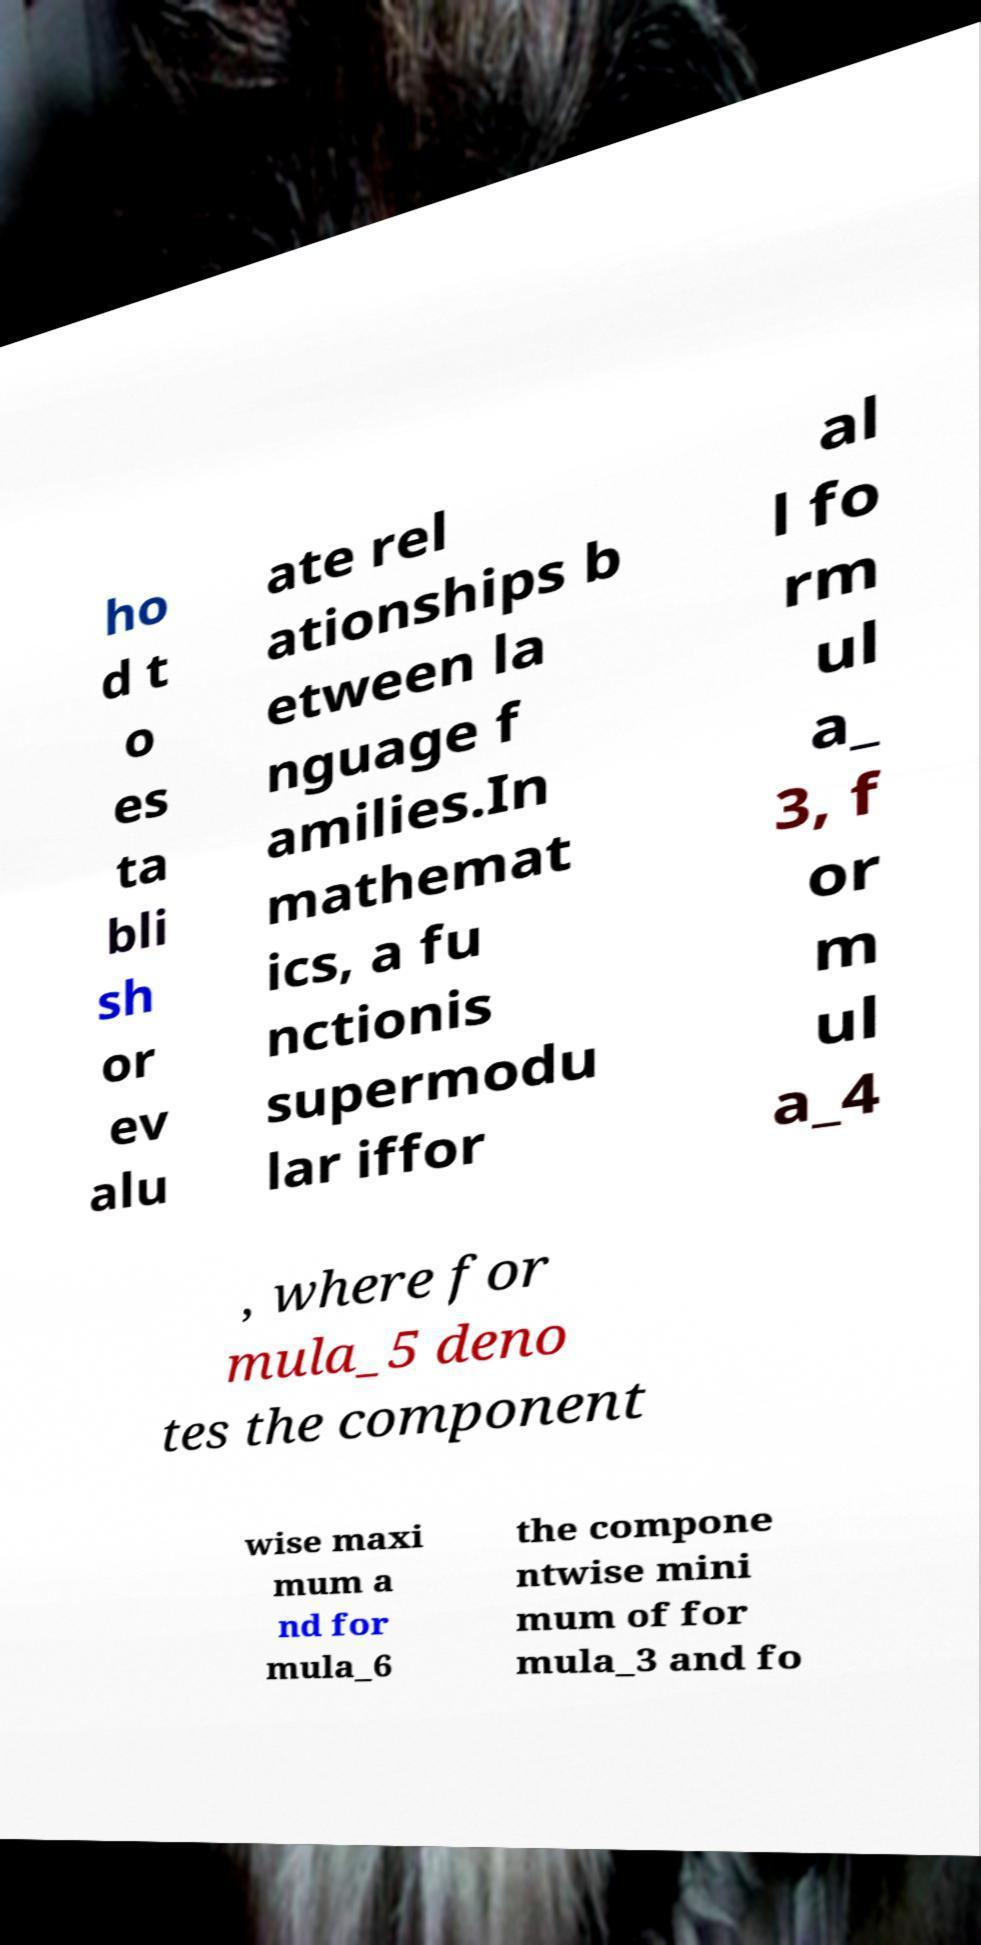Can you read and provide the text displayed in the image?This photo seems to have some interesting text. Can you extract and type it out for me? ho d t o es ta bli sh or ev alu ate rel ationships b etween la nguage f amilies.In mathemat ics, a fu nctionis supermodu lar iffor al l fo rm ul a_ 3, f or m ul a_4 , where for mula_5 deno tes the component wise maxi mum a nd for mula_6 the compone ntwise mini mum of for mula_3 and fo 